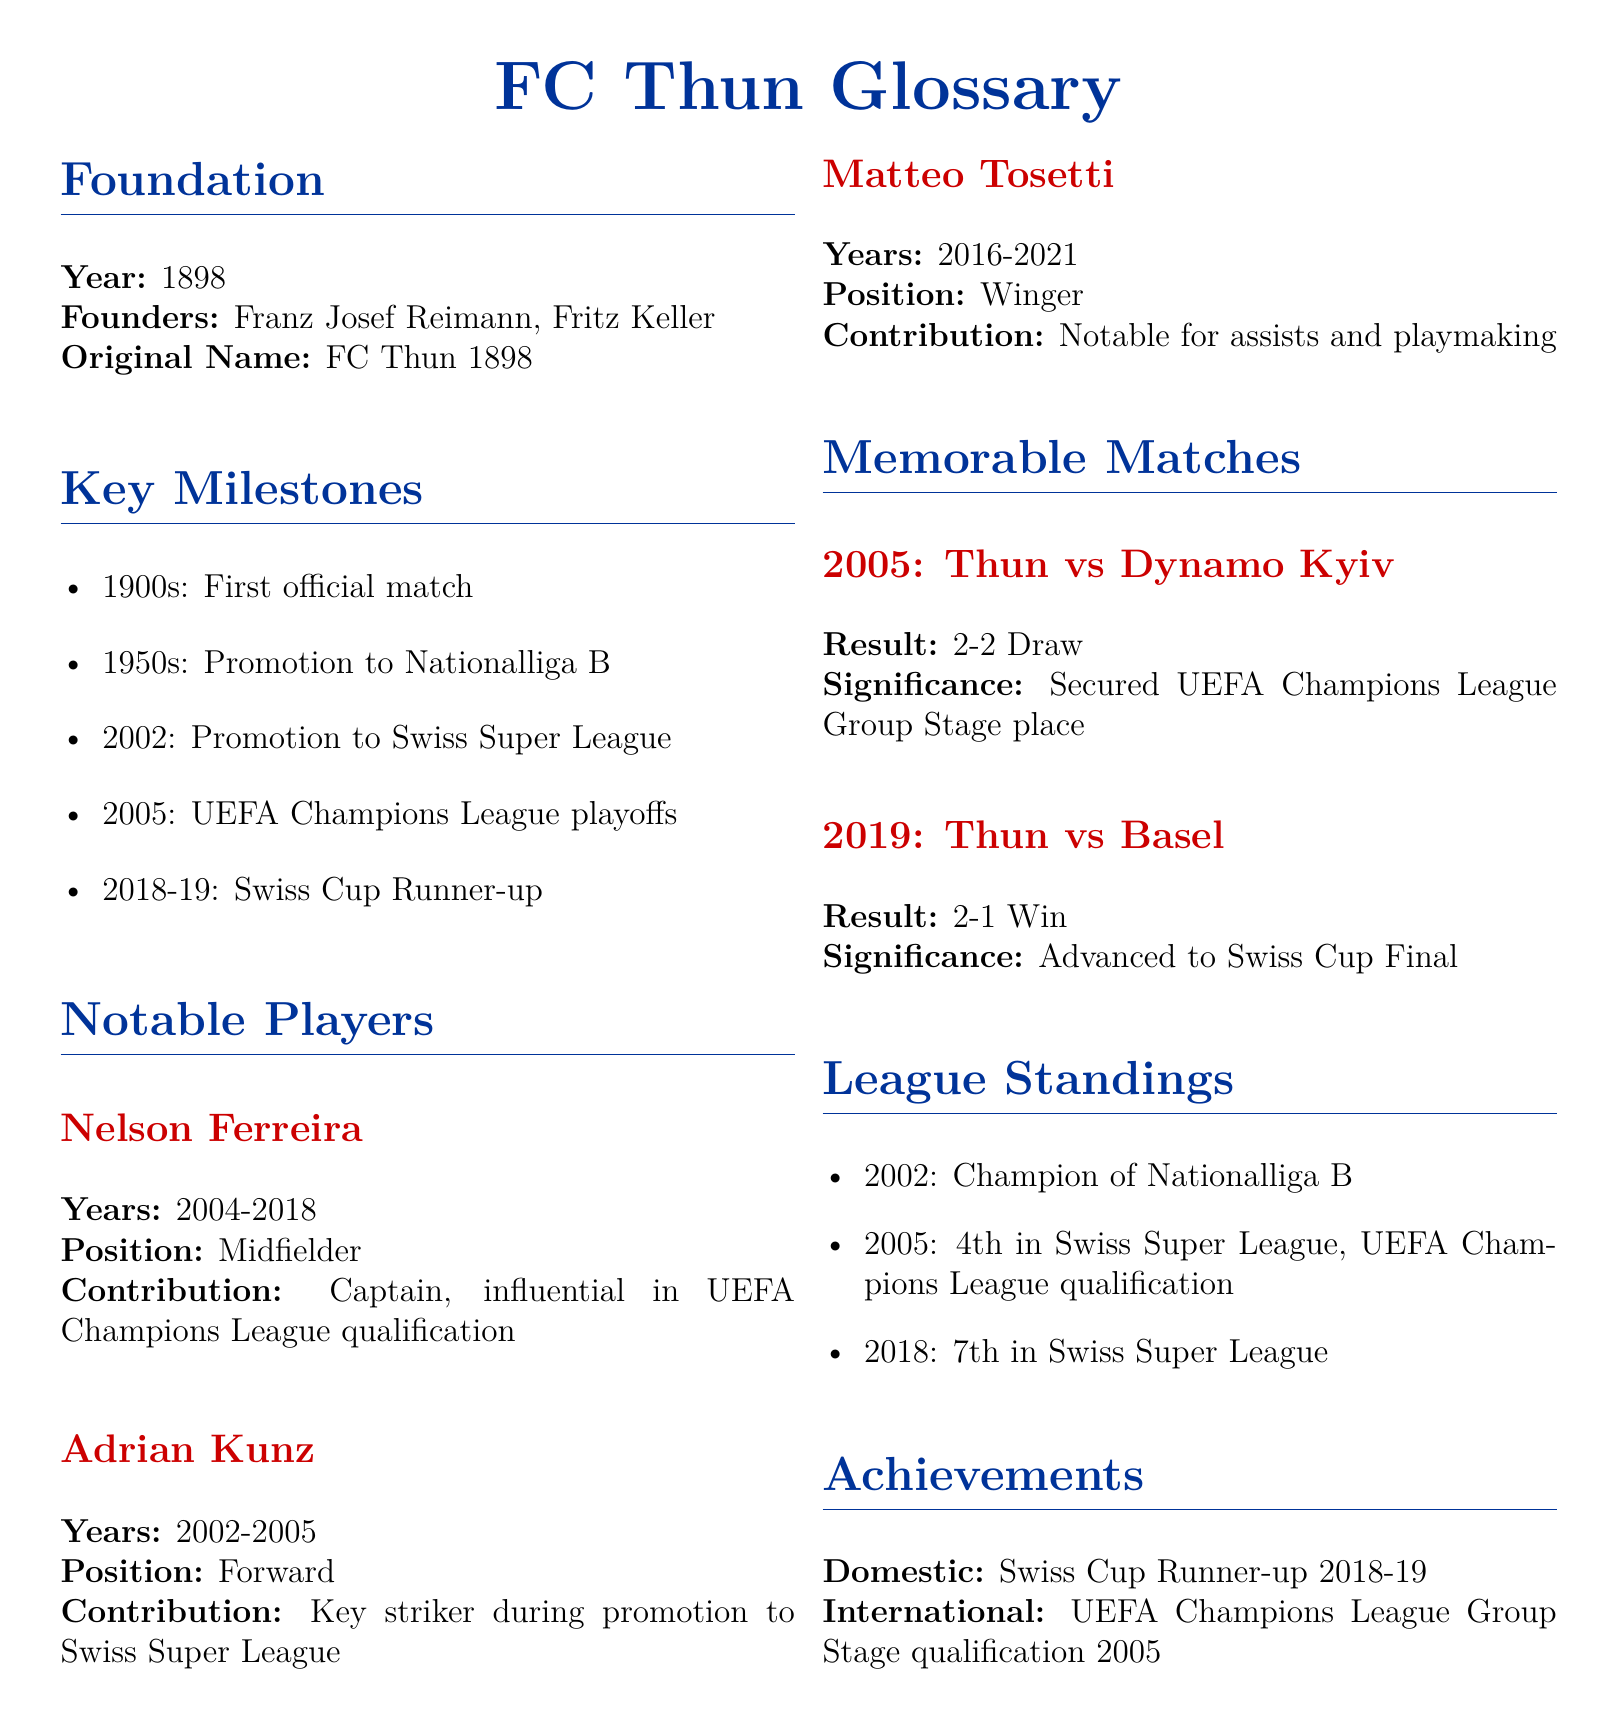What year was FC Thun founded? The foundation year is explicitly stated under the Foundation section of the document.
Answer: 1898 Who were the founders of FC Thun? The document lists the names of the founders in the Foundation section.
Answer: Franz Josef Reimann, Fritz Keller What position did Nelson Ferreira play? The document specifies the position of Nelson Ferreira in the Notable Players section.
Answer: Midfielder What significant event occurred in 2005 for FC Thun? The document highlights the importance of the year 2005 in the Key Milestones section.
Answer: UEFA Champions League playoffs What was FC Thun's league standing in 2002? The League Standings section provides specific standings information for that year.
Answer: Champion of Nationalliga B Which player was a key striker during the promotion to the Swiss Super League? The document identifies Adrian Kunz's role in the Notable Players section.
Answer: Adrian Kunz What significant match result occurred between Thun and Dynamo Kyiv in 2005? The Memorable Matches section details the outcome of the match in the year specified.
Answer: 2-2 Draw What was FC Thun's achievement in the Swiss Cup for the 2018-19 season? The Achievements section notes this specific accomplishment.
Answer: Runner-up What is the original name of FC Thun? The original name is provided in the Foundation section of the document.
Answer: FC Thun 1898 